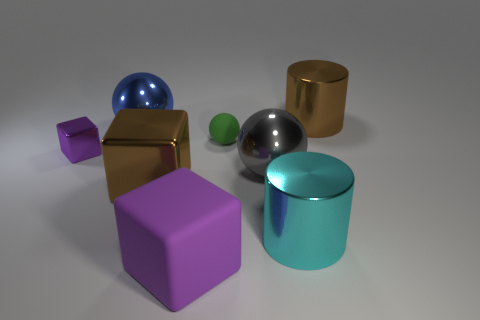There is a rubber object that is in front of the large cyan thing that is right of the large shiny block; what is its shape?
Give a very brief answer. Cube. Is the color of the big metal block the same as the rubber sphere?
Provide a short and direct response. No. How many gray things are either metallic spheres or matte objects?
Keep it short and to the point. 1. There is a big cyan metallic cylinder; are there any blue metallic balls on the left side of it?
Your response must be concise. Yes. How big is the purple matte thing?
Keep it short and to the point. Large. The gray shiny thing that is the same shape as the tiny green matte thing is what size?
Give a very brief answer. Large. There is a large purple matte object to the left of the cyan shiny thing; how many things are behind it?
Your response must be concise. 7. Are the brown thing that is on the right side of the big gray metallic ball and the brown thing that is left of the brown cylinder made of the same material?
Your answer should be compact. Yes. How many gray metallic things have the same shape as the green object?
Your response must be concise. 1. How many other things are the same color as the small metal object?
Your answer should be compact. 1. 